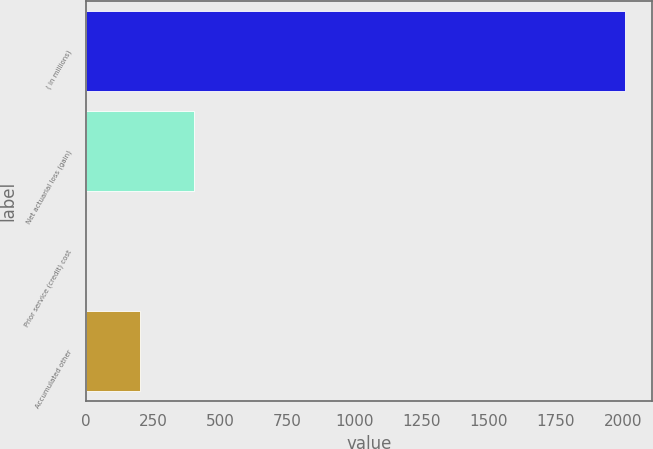Convert chart to OTSL. <chart><loc_0><loc_0><loc_500><loc_500><bar_chart><fcel>( in millions)<fcel>Net actuarial loss (gain)<fcel>Prior service (credit) cost<fcel>Accumulated other<nl><fcel>2008<fcel>401.92<fcel>0.4<fcel>201.16<nl></chart> 